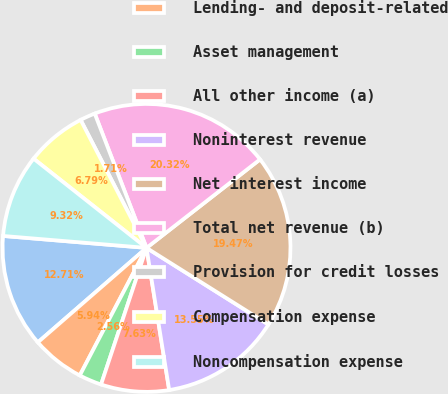<chart> <loc_0><loc_0><loc_500><loc_500><pie_chart><fcel>Year ended December 31 (in<fcel>Lending- and deposit-related<fcel>Asset management<fcel>All other income (a)<fcel>Noninterest revenue<fcel>Net interest income<fcel>Total net revenue (b)<fcel>Provision for credit losses<fcel>Compensation expense<fcel>Noncompensation expense<nl><fcel>12.71%<fcel>5.94%<fcel>2.56%<fcel>7.63%<fcel>13.55%<fcel>19.47%<fcel>20.32%<fcel>1.71%<fcel>6.79%<fcel>9.32%<nl></chart> 